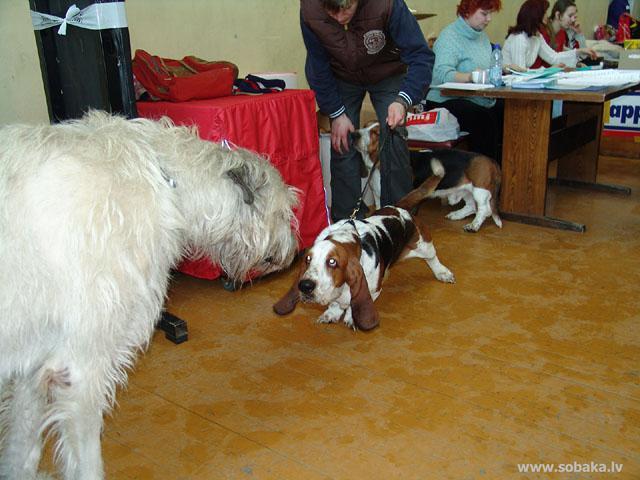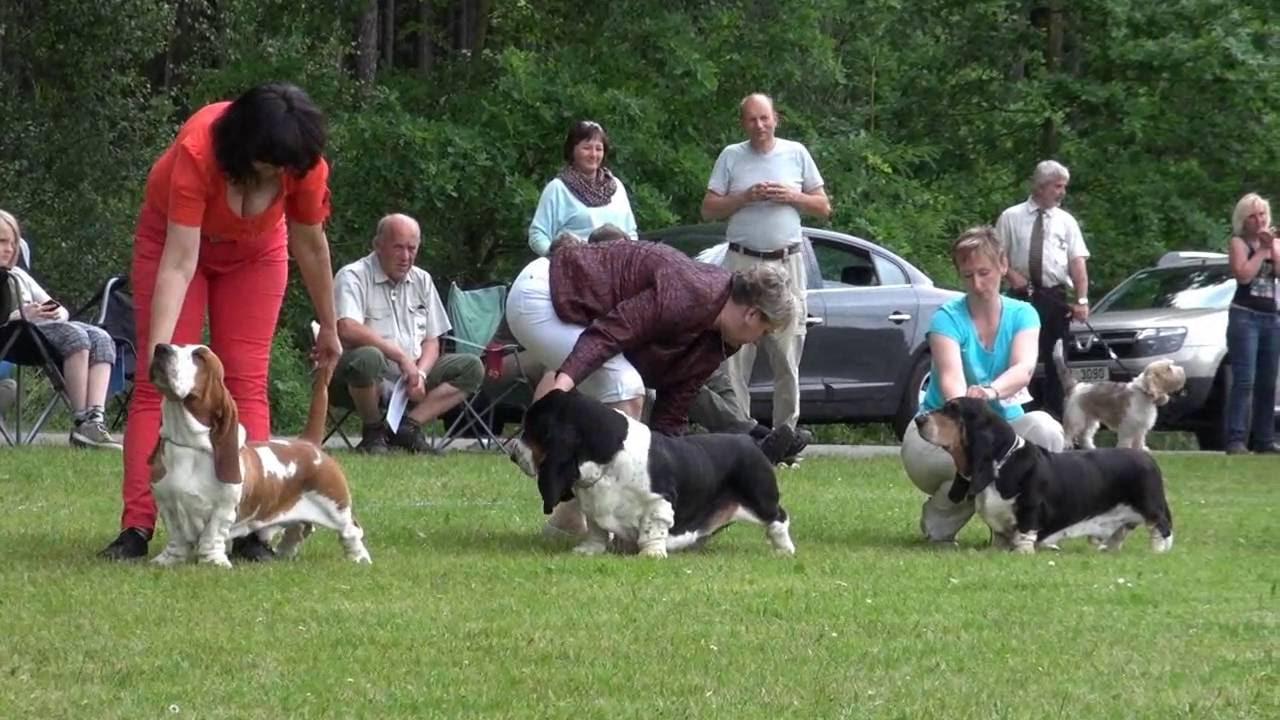The first image is the image on the left, the second image is the image on the right. For the images displayed, is the sentence "The rightmost image features a single basset hound, on a leash, with no face of a person visible." factually correct? Answer yes or no. No. 